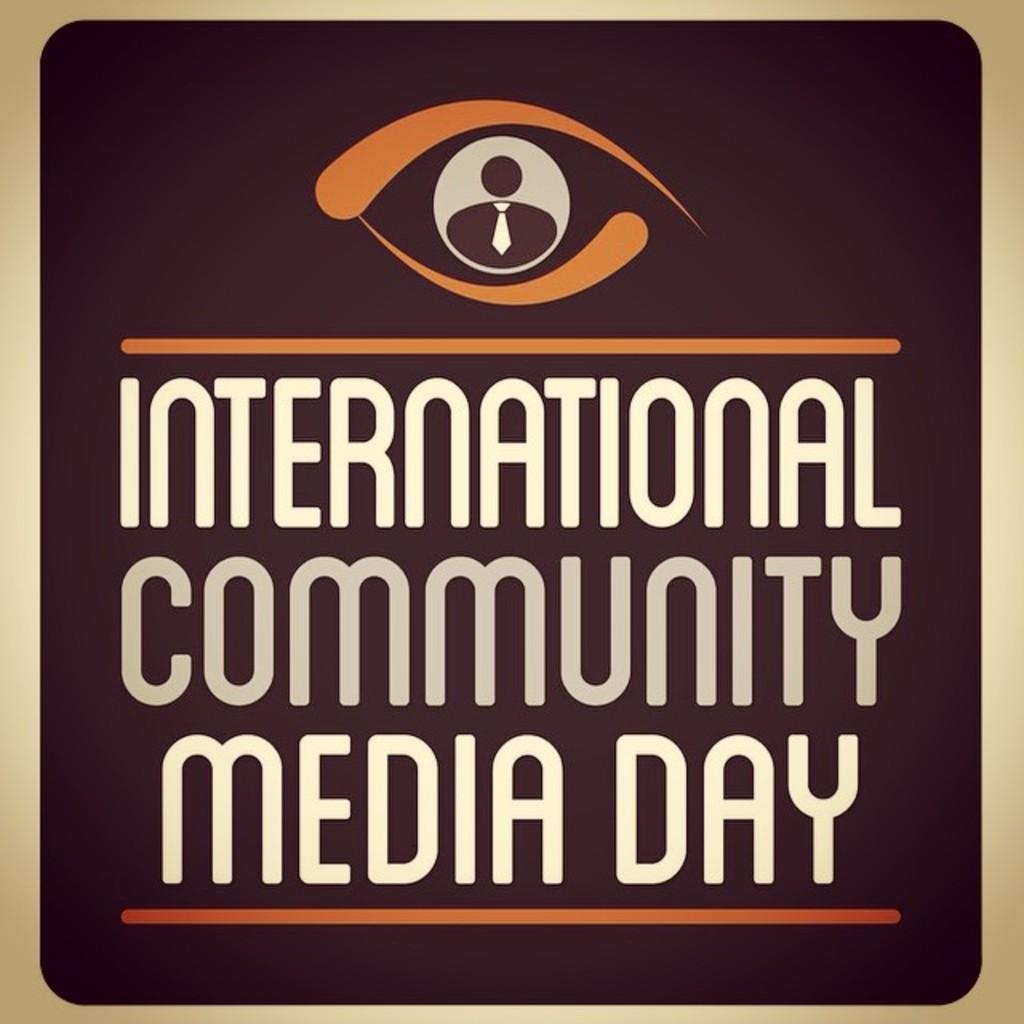<image>
Provide a brief description of the given image. A brown sign with a logo for International Community Media Day. 